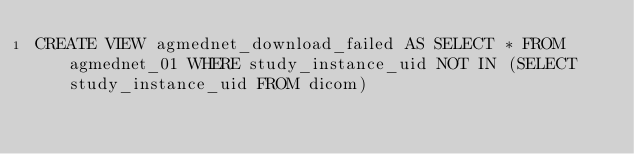Convert code to text. <code><loc_0><loc_0><loc_500><loc_500><_SQL_>CREATE VIEW agmednet_download_failed AS SELECT * FROM agmednet_01 WHERE study_instance_uid NOT IN (SELECT study_instance_uid FROM dicom)</code> 